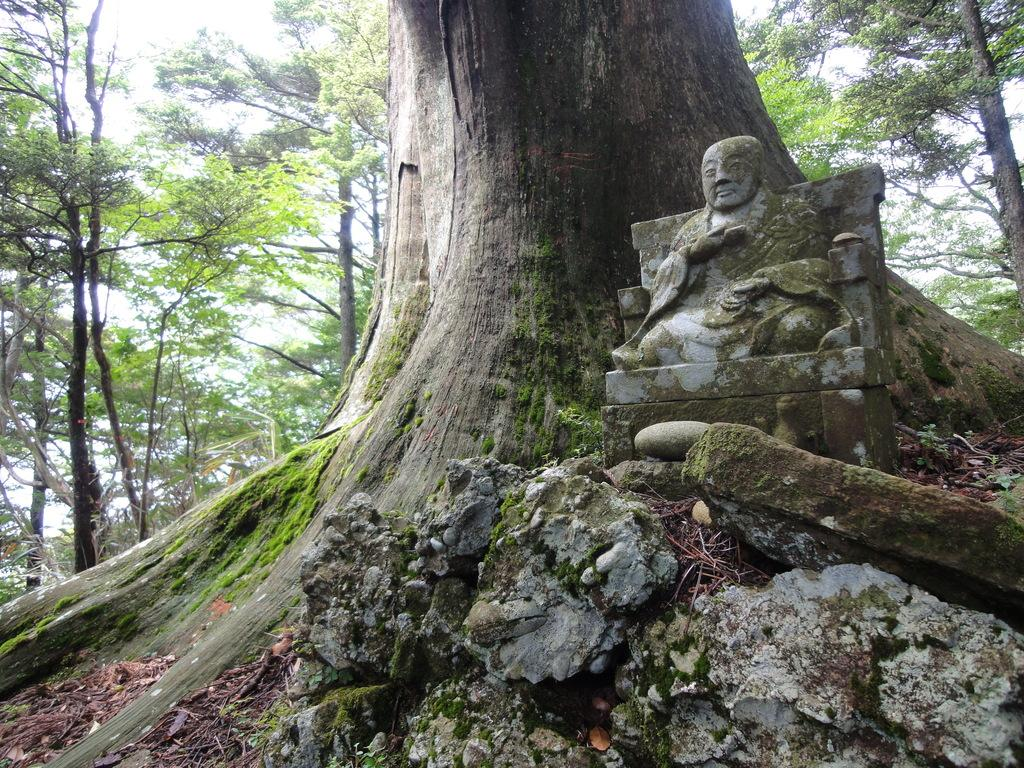What is the main subject in the front of the image? There is a sculpture in the front of the image. What other object can be seen in the image? There is a tree trunk in the image. What can be seen in the background of the image? There are trees in the background of the image. What month is depicted in the sculpture in the image? The sculpture does not depict a specific month; it is a sculpture and not a representation of a particular time. 